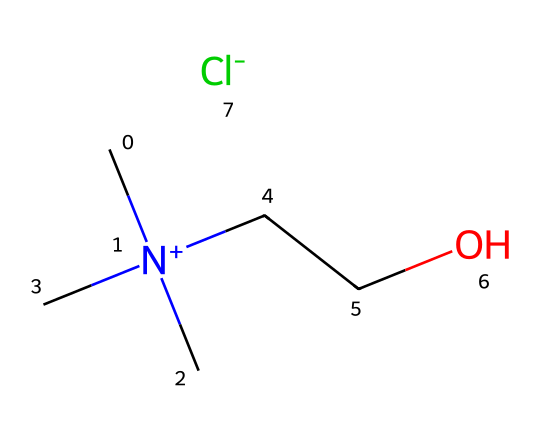What is the total number of carbon atoms in this ionic liquid? The structure shows a total of four carbon atoms: three in the trimethylammonium (C[N+](C)(C)) part and one in the ethoxy group (CCO).
Answer: four How many nitrogen atoms are present in the structure? The structure contains one nitrogen atom, which is represented by the "N" in the trimethylammonium group (C[N+](C)(C)).
Answer: one What type of ion is represented by the 'Cl' in this ionic liquid? The 'Cl' in the structure represents a chloride ion (Cl-), which acts as the counterion in ionic liquids.
Answer: chloride What is the role of the ethoxy group (CCO) in the structure? The ethoxy group provides stability and influences the solubility of the ionic liquid, enhancing its properties for electrolyte applications.
Answer: stability and solubility Why are ionic liquids considered good electrolytes for wearable devices? Ionic liquids have low volatility, good ionic conductivity, and can operate over a wide temperature range, making them ideal for use in wearable health monitoring devices.
Answer: good ionic conductivity How many total bonds are formed in this molecule? In this molecule, six single bonds are formed: three C–C, one C–N, and two C–O bonds, resulting in a total of six single bonds.
Answer: six 